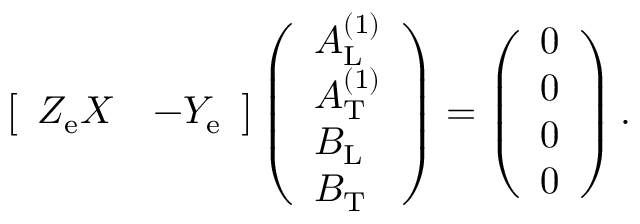Convert formula to latex. <formula><loc_0><loc_0><loc_500><loc_500>\begin{array} { r } { \left [ \begin{array} { l l } { Z _ { e } X } & { - Y _ { e } } \end{array} \right ] \left ( \begin{array} { l } { A _ { L } ^ { ( 1 ) } } \\ { A _ { T } ^ { ( 1 ) } } \\ { B _ { L } } \\ { B _ { T } } \end{array} \right ) = \left ( \begin{array} { l } { 0 } \\ { 0 } \\ { 0 } \\ { 0 } \end{array} \right ) . } \end{array}</formula> 